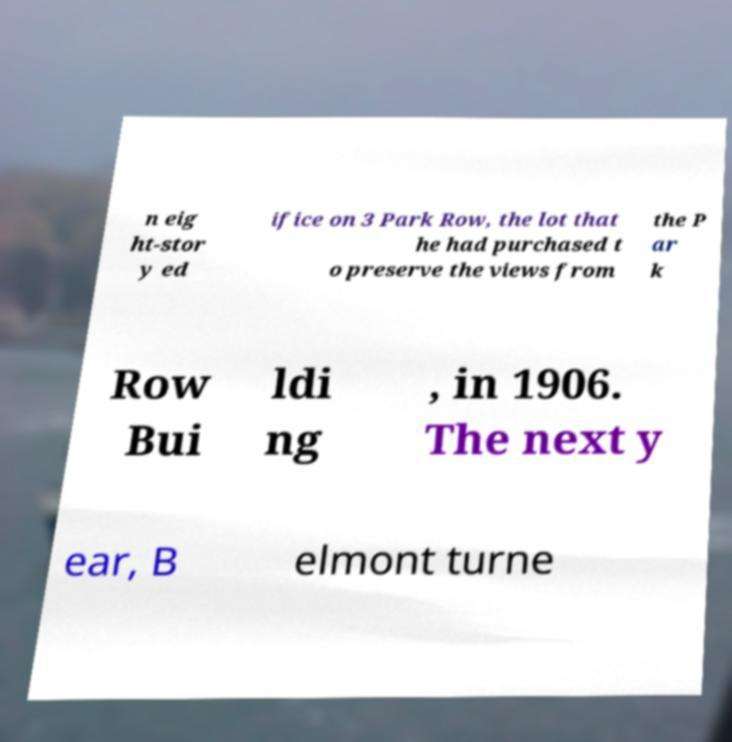Can you read and provide the text displayed in the image?This photo seems to have some interesting text. Can you extract and type it out for me? n eig ht-stor y ed ifice on 3 Park Row, the lot that he had purchased t o preserve the views from the P ar k Row Bui ldi ng , in 1906. The next y ear, B elmont turne 